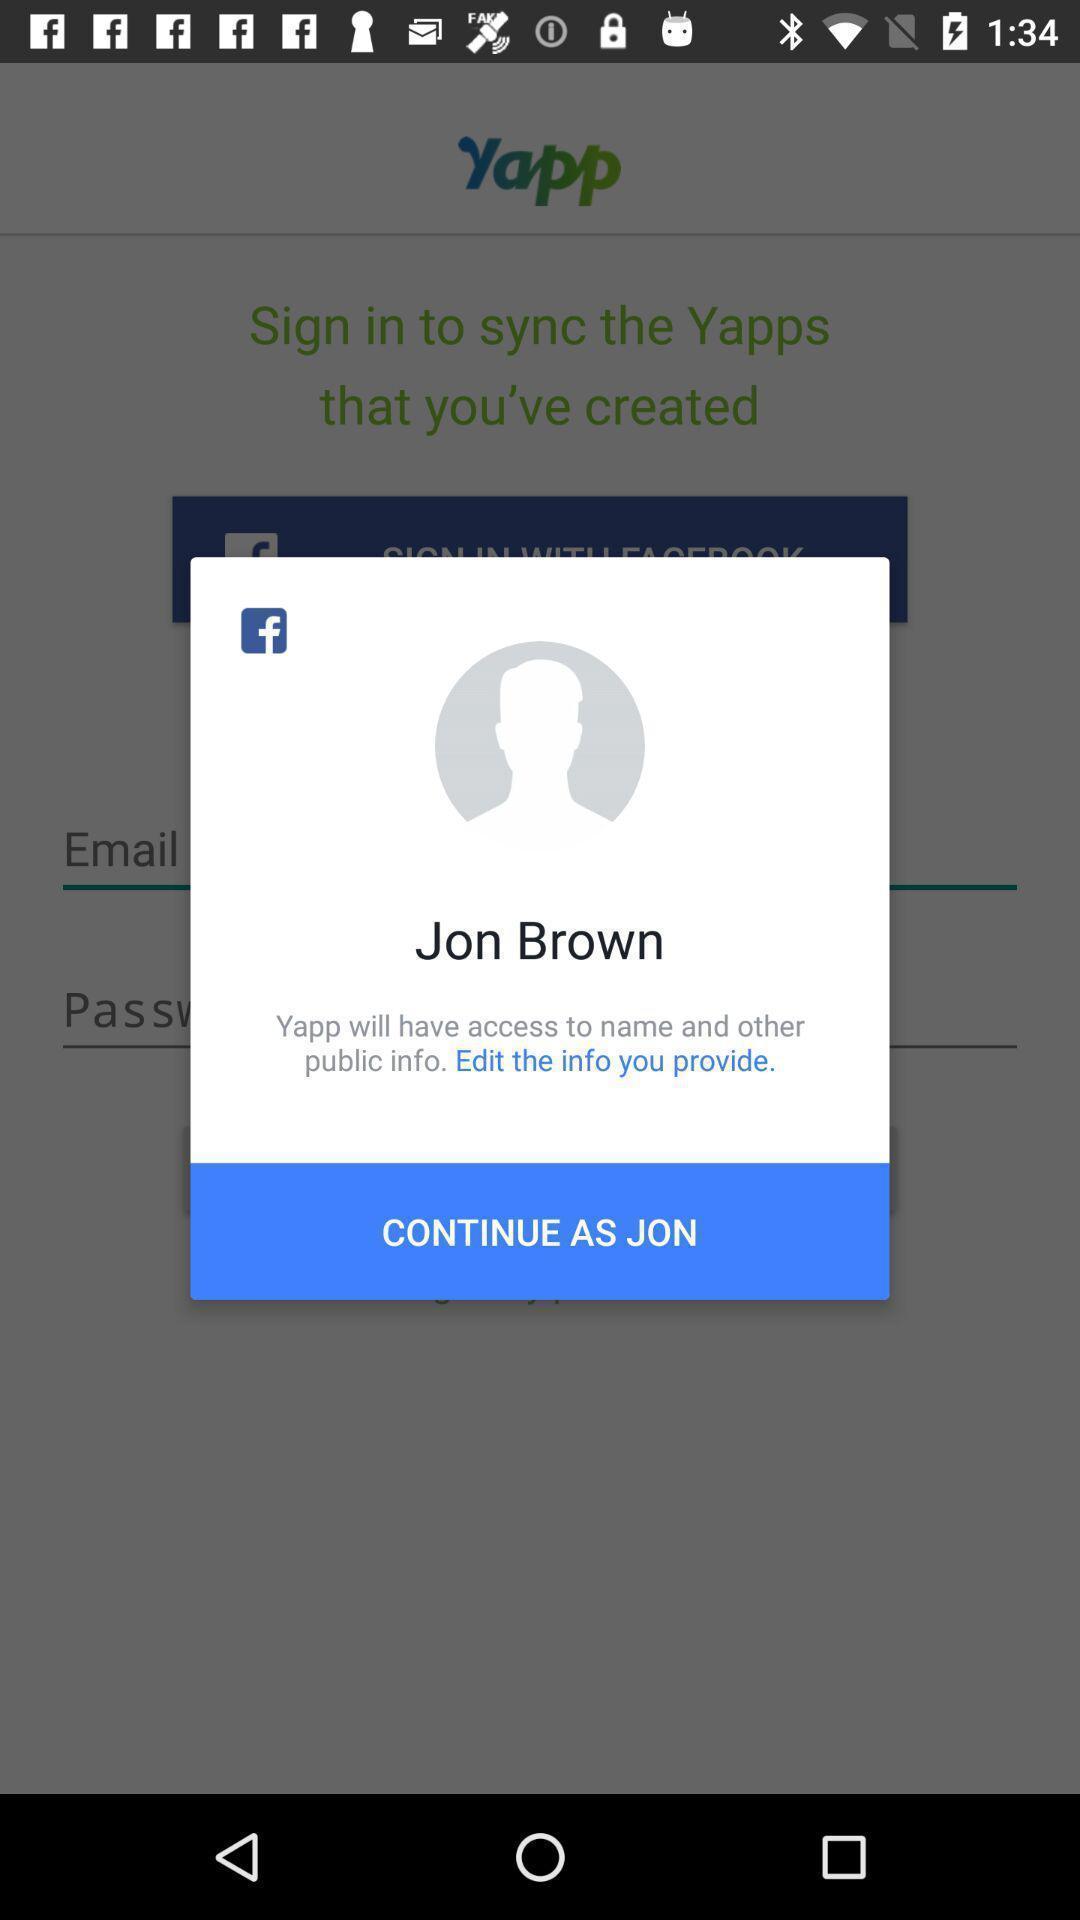Summarize the main components in this picture. Popup displaying continue as jon in social app. 